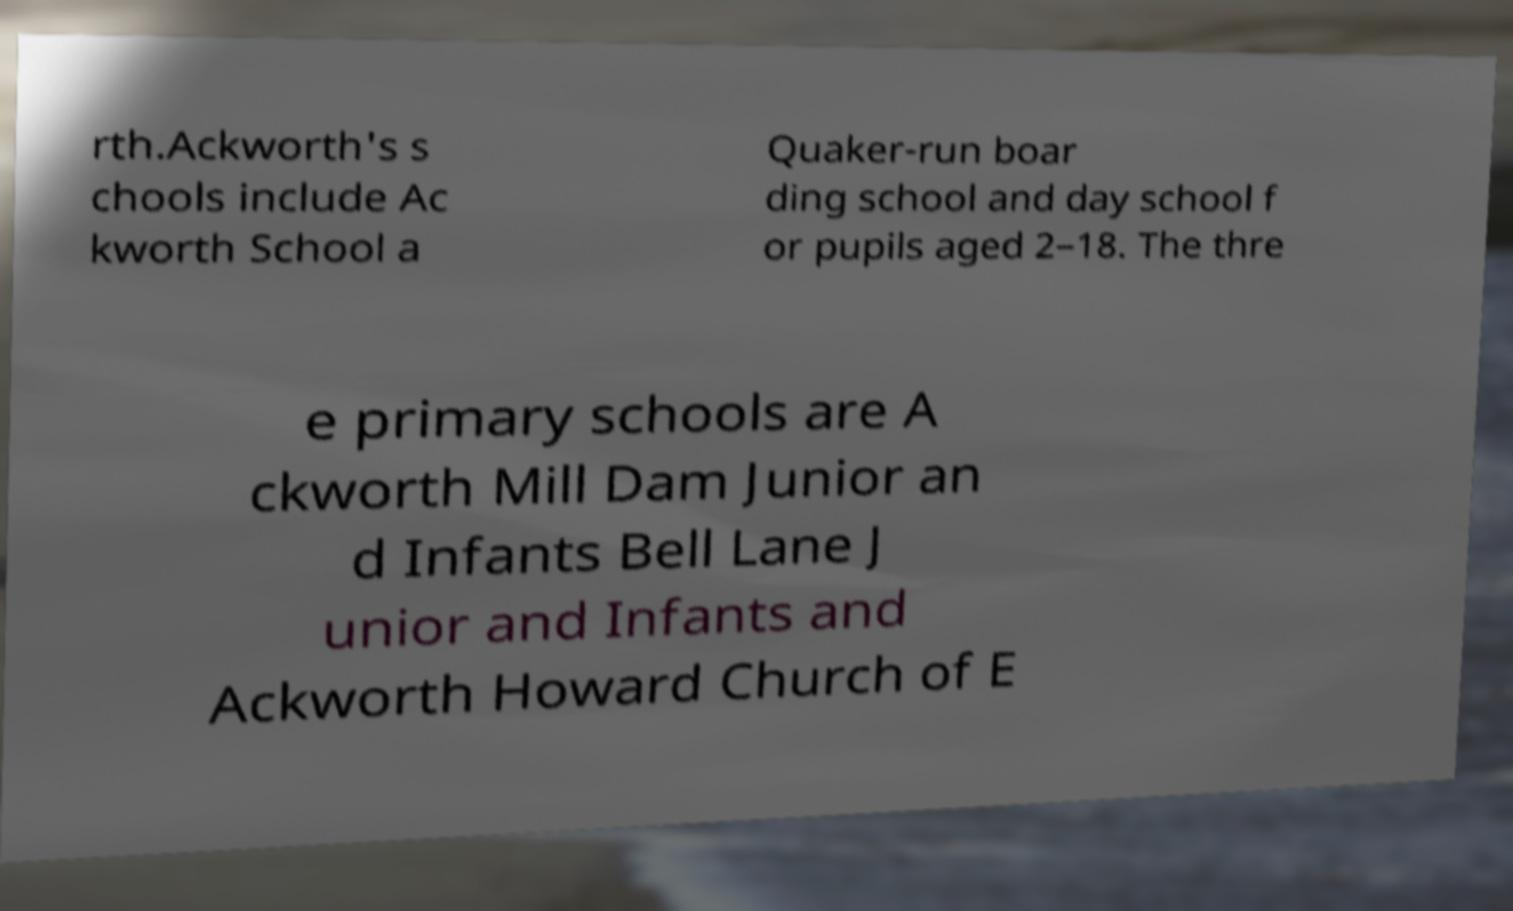I need the written content from this picture converted into text. Can you do that? rth.Ackworth's s chools include Ac kworth School a Quaker-run boar ding school and day school f or pupils aged 2–18. The thre e primary schools are A ckworth Mill Dam Junior an d Infants Bell Lane J unior and Infants and Ackworth Howard Church of E 